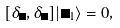<formula> <loc_0><loc_0><loc_500><loc_500>[ \delta _ { \Lambda } , \delta _ { \Xi } ] | \Phi _ { 1 } \rangle = 0 ,</formula> 